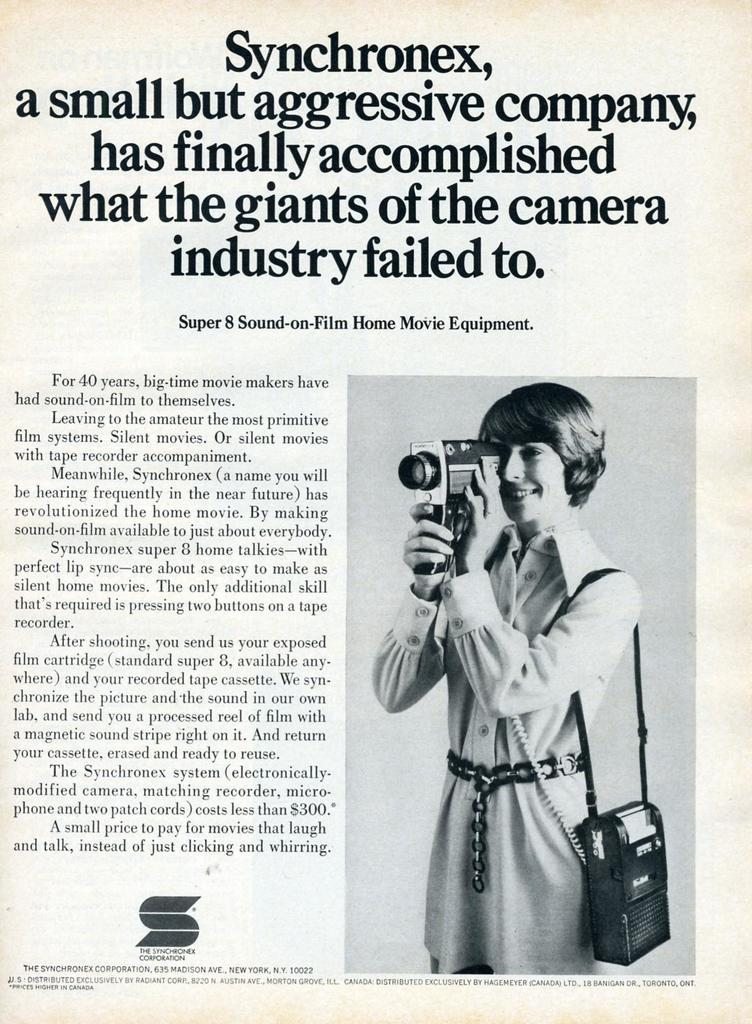What is present on the poster in the image? There is a poster in the image. What elements are included on the poster? The poster contains text, a picture, and objects. Can you see any bones on the poster in the image? There are no bones visible on the poster in the image. Is there any sense of shame conveyed by the poster in the image? The poster in the image does not convey any sense of shame, as it only contains text, a picture, and objects. 